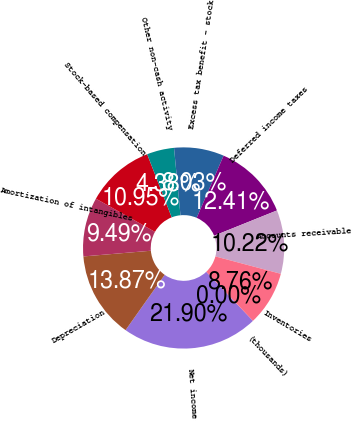Convert chart. <chart><loc_0><loc_0><loc_500><loc_500><pie_chart><fcel>(thousands)<fcel>Net income<fcel>Depreciation<fcel>Amortization of intangibles<fcel>Stock-based compensation<fcel>Other non-cash activity<fcel>Excess tax benefit - stock<fcel>Deferred income taxes<fcel>Accounts receivable<fcel>Inventories<nl><fcel>0.0%<fcel>21.9%<fcel>13.87%<fcel>9.49%<fcel>10.95%<fcel>4.38%<fcel>8.03%<fcel>12.41%<fcel>10.22%<fcel>8.76%<nl></chart> 